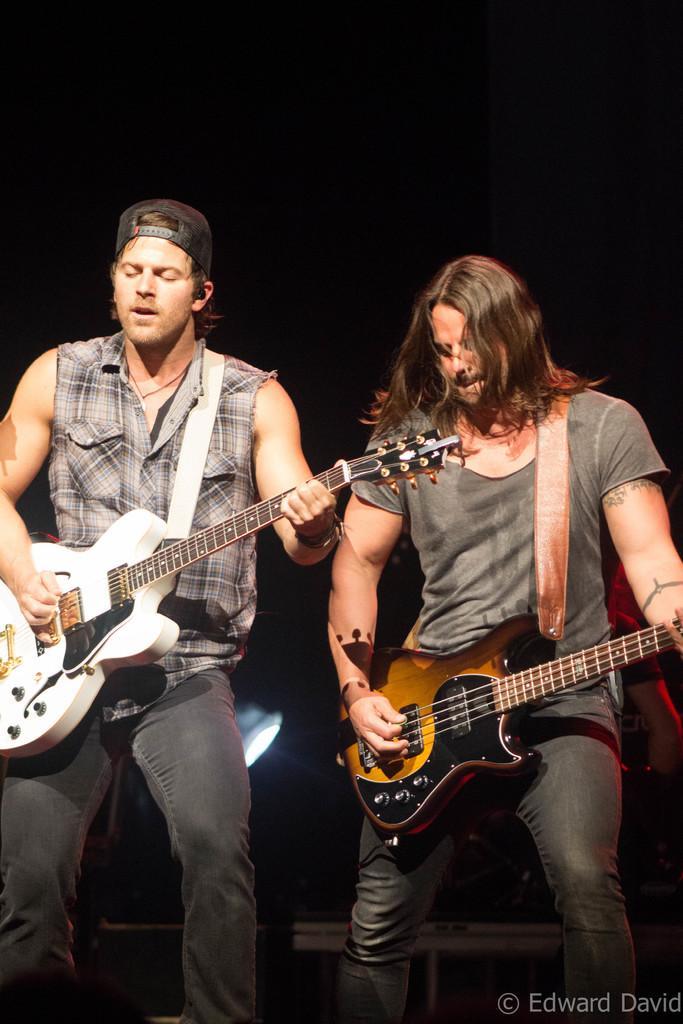Describe this image in one or two sentences. In this picture there are two men playing guitars. The person towards the left, he is wearing a check shirt and black trousers. The person towards the right, he is swearing a grey t shirt and black trousers and the background is dark and there is a light. 